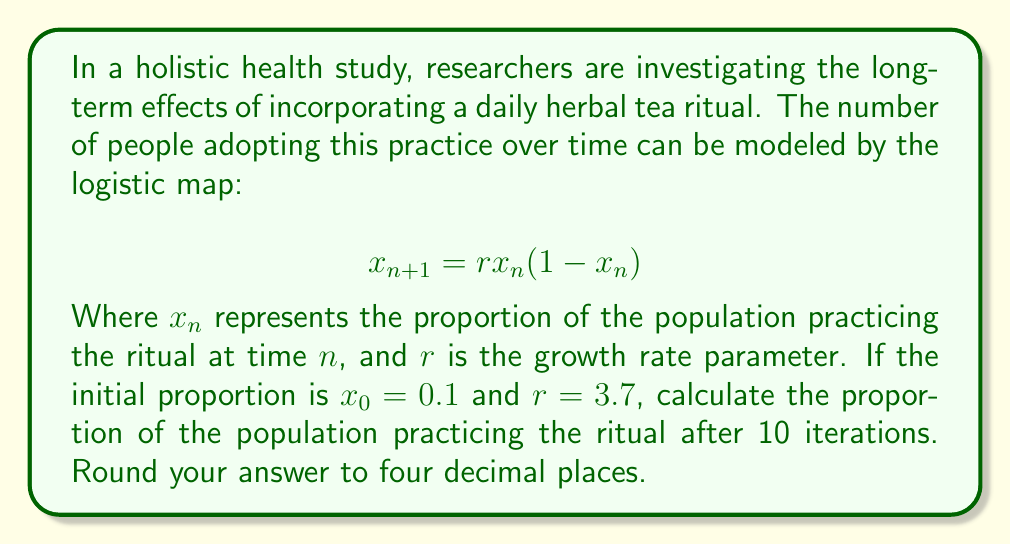Teach me how to tackle this problem. To solve this problem, we need to iterate the logistic map equation 10 times, starting with the initial value of $x_0 = 0.1$ and using $r = 3.7$. Let's go through this step-by-step:

1) First iteration ($n = 0$ to $n = 1$):
   $x_1 = 3.7 \cdot 0.1 \cdot (1 - 0.1) = 0.333$

2) Second iteration ($n = 1$ to $n = 2$):
   $x_2 = 3.7 \cdot 0.333 \cdot (1 - 0.333) = 0.8234$

3) Third iteration ($n = 2$ to $n = 3$):
   $x_3 = 3.7 \cdot 0.8234 \cdot (1 - 0.8234) = 0.5393$

4) Fourth iteration ($n = 3$ to $n = 4$):
   $x_4 = 3.7 \cdot 0.5393 \cdot (1 - 0.5393) = 0.9201$

5) Fifth iteration ($n = 4$ to $n = 5$):
   $x_5 = 3.7 \cdot 0.9201 \cdot (1 - 0.9201) = 0.2720$

6) Sixth iteration ($n = 5$ to $n = 6$):
   $x_6 = 3.7 \cdot 0.2720 \cdot (1 - 0.2720) = 0.7326$

7) Seventh iteration ($n = 6$ to $n = 7$):
   $x_7 = 3.7 \cdot 0.7326 \cdot (1 - 0.7326) = 0.7254$

8) Eighth iteration ($n = 7$ to $n = 8$):
   $x_8 = 3.7 \cdot 0.7254 \cdot (1 - 0.7254) = 0.7372$

9) Ninth iteration ($n = 8$ to $n = 9$):
   $x_9 = 3.7 \cdot 0.7372 \cdot (1 - 0.7372) = 0.7179$

10) Tenth iteration ($n = 9$ to $n = 10$):
    $x_{10} = 3.7 \cdot 0.7179 \cdot (1 - 0.7179) = 0.7504$

Rounding to four decimal places, we get 0.7504.
Answer: 0.7504 